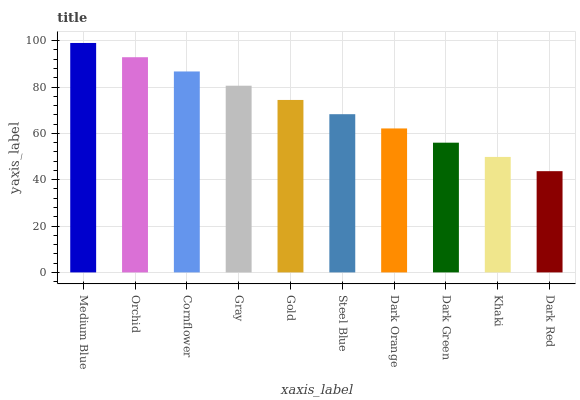Is Dark Red the minimum?
Answer yes or no. Yes. Is Medium Blue the maximum?
Answer yes or no. Yes. Is Orchid the minimum?
Answer yes or no. No. Is Orchid the maximum?
Answer yes or no. No. Is Medium Blue greater than Orchid?
Answer yes or no. Yes. Is Orchid less than Medium Blue?
Answer yes or no. Yes. Is Orchid greater than Medium Blue?
Answer yes or no. No. Is Medium Blue less than Orchid?
Answer yes or no. No. Is Gold the high median?
Answer yes or no. Yes. Is Steel Blue the low median?
Answer yes or no. Yes. Is Cornflower the high median?
Answer yes or no. No. Is Medium Blue the low median?
Answer yes or no. No. 